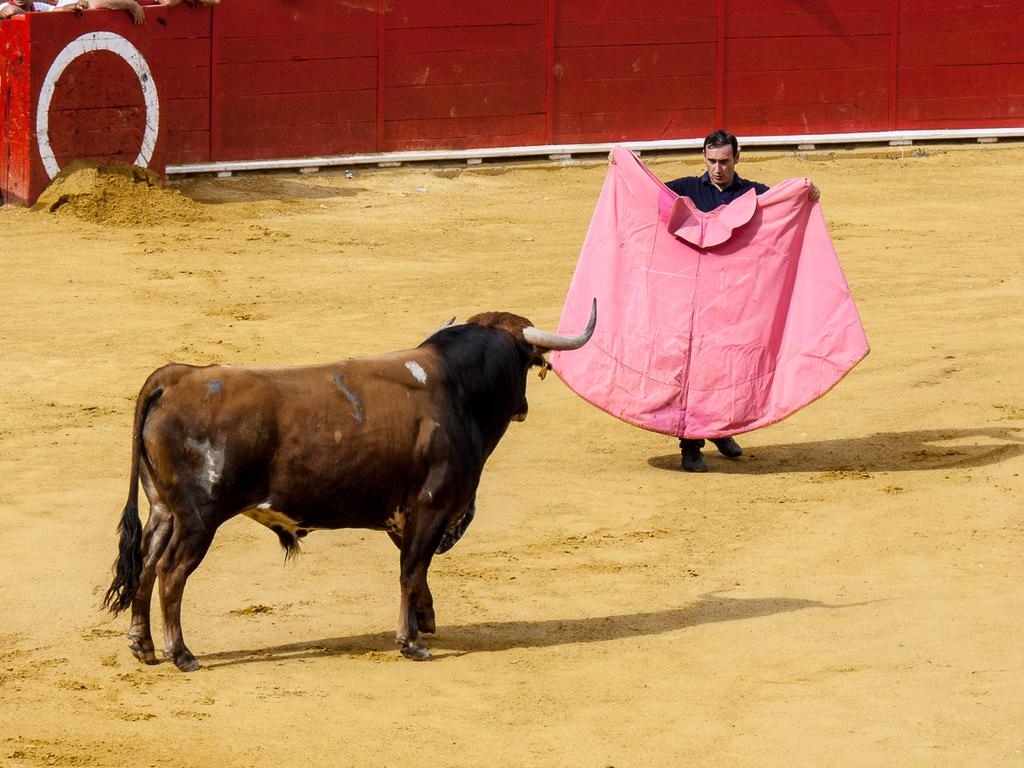What animal is present in the image? There is a bull in the image. Who is in front of the bull? There is a man in front of the bull. What is the man holding? The man is holding a cloth. What can be seen in the background of the image? There is a red wooden wall in the background of the image. How many friends does the bull have in the image? There is no indication of friends in the image; it only features a bull and a man. Which knee is the bull using to support itself in the image? The image does not show the bull's knees, as it is a side view of the bull. 